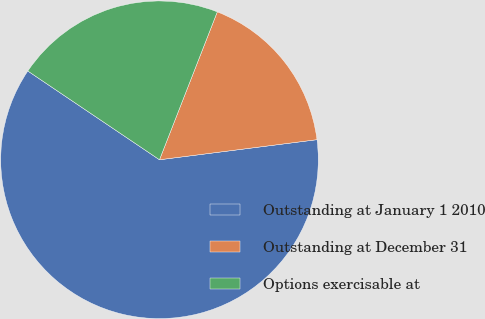<chart> <loc_0><loc_0><loc_500><loc_500><pie_chart><fcel>Outstanding at January 1 2010<fcel>Outstanding at December 31<fcel>Options exercisable at<nl><fcel>61.46%<fcel>17.05%<fcel>21.49%<nl></chart> 